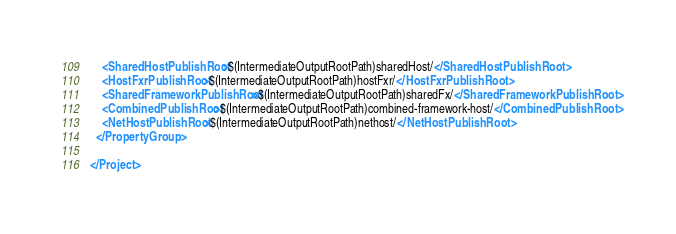<code> <loc_0><loc_0><loc_500><loc_500><_XML_>    <SharedHostPublishRoot>$(IntermediateOutputRootPath)sharedHost/</SharedHostPublishRoot>
    <HostFxrPublishRoot>$(IntermediateOutputRootPath)hostFxr/</HostFxrPublishRoot>
    <SharedFrameworkPublishRoot>$(IntermediateOutputRootPath)sharedFx/</SharedFrameworkPublishRoot>
    <CombinedPublishRoot>$(IntermediateOutputRootPath)combined-framework-host/</CombinedPublishRoot>
    <NetHostPublishRoot>$(IntermediateOutputRootPath)nethost/</NetHostPublishRoot>
  </PropertyGroup>

</Project>
</code> 